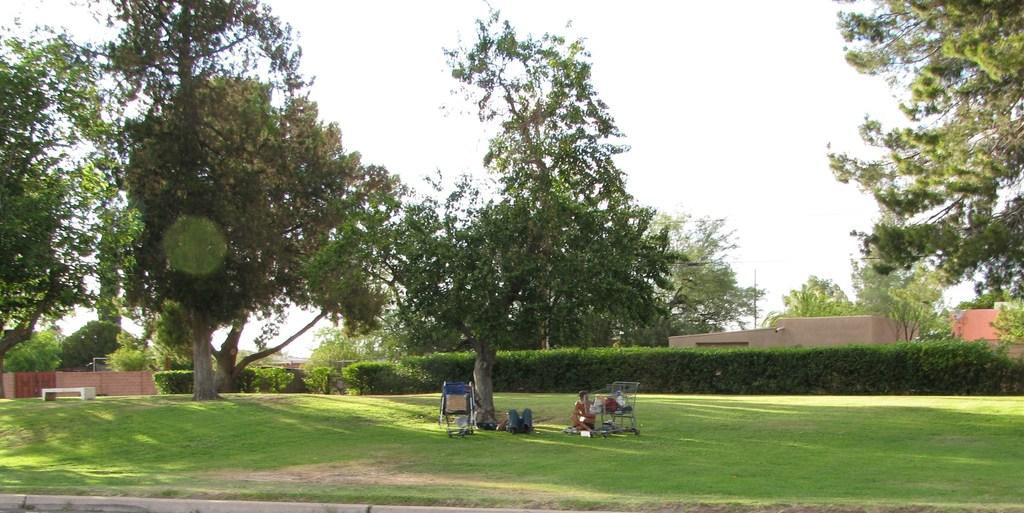What type of vehicles are in the middle of the image? There are baby vehicles in the middle of the image. Can you describe the people in the image? There are people in the image, but their specific actions or characteristics are not mentioned in the facts. What type of natural elements are present in the image? There are trees and bushes in the image. What is visible at the top of the image? The sky is visible at the top of the image. What might be located on the right side of the image? There may be rooms on the right side of the image. What type of beam is holding up the truck in the image? There is no truck present in the image, and therefore no beam is needed to hold it up. 